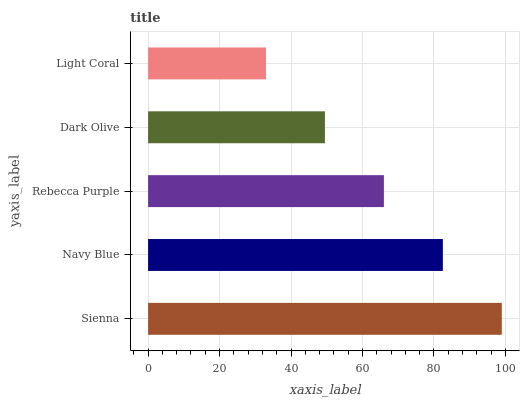Is Light Coral the minimum?
Answer yes or no. Yes. Is Sienna the maximum?
Answer yes or no. Yes. Is Navy Blue the minimum?
Answer yes or no. No. Is Navy Blue the maximum?
Answer yes or no. No. Is Sienna greater than Navy Blue?
Answer yes or no. Yes. Is Navy Blue less than Sienna?
Answer yes or no. Yes. Is Navy Blue greater than Sienna?
Answer yes or no. No. Is Sienna less than Navy Blue?
Answer yes or no. No. Is Rebecca Purple the high median?
Answer yes or no. Yes. Is Rebecca Purple the low median?
Answer yes or no. Yes. Is Sienna the high median?
Answer yes or no. No. Is Navy Blue the low median?
Answer yes or no. No. 